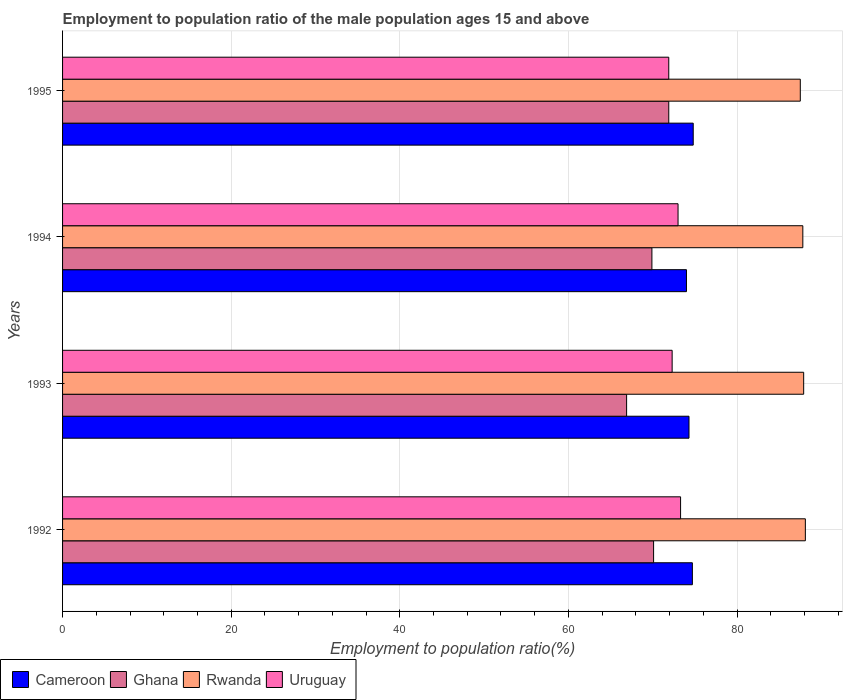How many groups of bars are there?
Your response must be concise. 4. Are the number of bars per tick equal to the number of legend labels?
Ensure brevity in your answer.  Yes. How many bars are there on the 3rd tick from the top?
Make the answer very short. 4. How many bars are there on the 2nd tick from the bottom?
Provide a short and direct response. 4. What is the label of the 1st group of bars from the top?
Keep it short and to the point. 1995. In how many cases, is the number of bars for a given year not equal to the number of legend labels?
Give a very brief answer. 0. What is the employment to population ratio in Cameroon in 1995?
Ensure brevity in your answer.  74.8. Across all years, what is the maximum employment to population ratio in Cameroon?
Ensure brevity in your answer.  74.8. Across all years, what is the minimum employment to population ratio in Cameroon?
Your response must be concise. 74. What is the total employment to population ratio in Ghana in the graph?
Ensure brevity in your answer.  278.8. What is the difference between the employment to population ratio in Cameroon in 1992 and that in 1993?
Make the answer very short. 0.4. What is the average employment to population ratio in Rwanda per year?
Offer a terse response. 87.83. In the year 1995, what is the difference between the employment to population ratio in Uruguay and employment to population ratio in Rwanda?
Your answer should be compact. -15.6. What is the ratio of the employment to population ratio in Rwanda in 1992 to that in 1995?
Your answer should be compact. 1.01. Is the difference between the employment to population ratio in Uruguay in 1993 and 1994 greater than the difference between the employment to population ratio in Rwanda in 1993 and 1994?
Ensure brevity in your answer.  No. What is the difference between the highest and the second highest employment to population ratio in Cameroon?
Offer a terse response. 0.1. What is the difference between the highest and the lowest employment to population ratio in Cameroon?
Keep it short and to the point. 0.8. In how many years, is the employment to population ratio in Cameroon greater than the average employment to population ratio in Cameroon taken over all years?
Your answer should be very brief. 2. What does the 1st bar from the top in 1992 represents?
Offer a very short reply. Uruguay. What does the 4th bar from the bottom in 1995 represents?
Offer a very short reply. Uruguay. How many bars are there?
Provide a short and direct response. 16. Are all the bars in the graph horizontal?
Provide a succinct answer. Yes. How many years are there in the graph?
Offer a terse response. 4. Are the values on the major ticks of X-axis written in scientific E-notation?
Give a very brief answer. No. Does the graph contain any zero values?
Your answer should be very brief. No. Does the graph contain grids?
Offer a very short reply. Yes. How many legend labels are there?
Make the answer very short. 4. How are the legend labels stacked?
Make the answer very short. Horizontal. What is the title of the graph?
Offer a terse response. Employment to population ratio of the male population ages 15 and above. What is the label or title of the X-axis?
Offer a very short reply. Employment to population ratio(%). What is the label or title of the Y-axis?
Provide a short and direct response. Years. What is the Employment to population ratio(%) in Cameroon in 1992?
Provide a succinct answer. 74.7. What is the Employment to population ratio(%) in Ghana in 1992?
Keep it short and to the point. 70.1. What is the Employment to population ratio(%) in Rwanda in 1992?
Your answer should be compact. 88.1. What is the Employment to population ratio(%) in Uruguay in 1992?
Provide a short and direct response. 73.3. What is the Employment to population ratio(%) of Cameroon in 1993?
Make the answer very short. 74.3. What is the Employment to population ratio(%) of Ghana in 1993?
Keep it short and to the point. 66.9. What is the Employment to population ratio(%) in Rwanda in 1993?
Your answer should be compact. 87.9. What is the Employment to population ratio(%) in Uruguay in 1993?
Offer a very short reply. 72.3. What is the Employment to population ratio(%) of Cameroon in 1994?
Your answer should be compact. 74. What is the Employment to population ratio(%) in Ghana in 1994?
Provide a succinct answer. 69.9. What is the Employment to population ratio(%) in Rwanda in 1994?
Your response must be concise. 87.8. What is the Employment to population ratio(%) in Uruguay in 1994?
Your response must be concise. 73. What is the Employment to population ratio(%) of Cameroon in 1995?
Provide a short and direct response. 74.8. What is the Employment to population ratio(%) in Ghana in 1995?
Offer a terse response. 71.9. What is the Employment to population ratio(%) of Rwanda in 1995?
Your answer should be compact. 87.5. What is the Employment to population ratio(%) in Uruguay in 1995?
Offer a very short reply. 71.9. Across all years, what is the maximum Employment to population ratio(%) in Cameroon?
Your response must be concise. 74.8. Across all years, what is the maximum Employment to population ratio(%) of Ghana?
Ensure brevity in your answer.  71.9. Across all years, what is the maximum Employment to population ratio(%) of Rwanda?
Make the answer very short. 88.1. Across all years, what is the maximum Employment to population ratio(%) in Uruguay?
Provide a succinct answer. 73.3. Across all years, what is the minimum Employment to population ratio(%) in Ghana?
Provide a short and direct response. 66.9. Across all years, what is the minimum Employment to population ratio(%) in Rwanda?
Provide a succinct answer. 87.5. Across all years, what is the minimum Employment to population ratio(%) in Uruguay?
Your answer should be very brief. 71.9. What is the total Employment to population ratio(%) of Cameroon in the graph?
Offer a terse response. 297.8. What is the total Employment to population ratio(%) of Ghana in the graph?
Offer a very short reply. 278.8. What is the total Employment to population ratio(%) in Rwanda in the graph?
Make the answer very short. 351.3. What is the total Employment to population ratio(%) in Uruguay in the graph?
Your answer should be compact. 290.5. What is the difference between the Employment to population ratio(%) in Ghana in 1992 and that in 1994?
Make the answer very short. 0.2. What is the difference between the Employment to population ratio(%) of Rwanda in 1992 and that in 1994?
Give a very brief answer. 0.3. What is the difference between the Employment to population ratio(%) in Cameroon in 1992 and that in 1995?
Your answer should be very brief. -0.1. What is the difference between the Employment to population ratio(%) of Rwanda in 1992 and that in 1995?
Provide a short and direct response. 0.6. What is the difference between the Employment to population ratio(%) of Uruguay in 1992 and that in 1995?
Your answer should be very brief. 1.4. What is the difference between the Employment to population ratio(%) in Cameroon in 1993 and that in 1994?
Provide a succinct answer. 0.3. What is the difference between the Employment to population ratio(%) in Rwanda in 1993 and that in 1994?
Your response must be concise. 0.1. What is the difference between the Employment to population ratio(%) in Cameroon in 1993 and that in 1995?
Ensure brevity in your answer.  -0.5. What is the difference between the Employment to population ratio(%) of Ghana in 1993 and that in 1995?
Your response must be concise. -5. What is the difference between the Employment to population ratio(%) in Rwanda in 1993 and that in 1995?
Provide a short and direct response. 0.4. What is the difference between the Employment to population ratio(%) in Cameroon in 1992 and the Employment to population ratio(%) in Ghana in 1993?
Offer a very short reply. 7.8. What is the difference between the Employment to population ratio(%) of Cameroon in 1992 and the Employment to population ratio(%) of Rwanda in 1993?
Give a very brief answer. -13.2. What is the difference between the Employment to population ratio(%) of Ghana in 1992 and the Employment to population ratio(%) of Rwanda in 1993?
Give a very brief answer. -17.8. What is the difference between the Employment to population ratio(%) of Ghana in 1992 and the Employment to population ratio(%) of Uruguay in 1993?
Offer a terse response. -2.2. What is the difference between the Employment to population ratio(%) of Rwanda in 1992 and the Employment to population ratio(%) of Uruguay in 1993?
Offer a very short reply. 15.8. What is the difference between the Employment to population ratio(%) of Cameroon in 1992 and the Employment to population ratio(%) of Ghana in 1994?
Your response must be concise. 4.8. What is the difference between the Employment to population ratio(%) of Cameroon in 1992 and the Employment to population ratio(%) of Rwanda in 1994?
Ensure brevity in your answer.  -13.1. What is the difference between the Employment to population ratio(%) in Cameroon in 1992 and the Employment to population ratio(%) in Uruguay in 1994?
Make the answer very short. 1.7. What is the difference between the Employment to population ratio(%) of Ghana in 1992 and the Employment to population ratio(%) of Rwanda in 1994?
Provide a succinct answer. -17.7. What is the difference between the Employment to population ratio(%) of Rwanda in 1992 and the Employment to population ratio(%) of Uruguay in 1994?
Your response must be concise. 15.1. What is the difference between the Employment to population ratio(%) in Cameroon in 1992 and the Employment to population ratio(%) in Ghana in 1995?
Ensure brevity in your answer.  2.8. What is the difference between the Employment to population ratio(%) in Cameroon in 1992 and the Employment to population ratio(%) in Rwanda in 1995?
Make the answer very short. -12.8. What is the difference between the Employment to population ratio(%) of Cameroon in 1992 and the Employment to population ratio(%) of Uruguay in 1995?
Give a very brief answer. 2.8. What is the difference between the Employment to population ratio(%) of Ghana in 1992 and the Employment to population ratio(%) of Rwanda in 1995?
Make the answer very short. -17.4. What is the difference between the Employment to population ratio(%) of Ghana in 1992 and the Employment to population ratio(%) of Uruguay in 1995?
Offer a terse response. -1.8. What is the difference between the Employment to population ratio(%) of Rwanda in 1992 and the Employment to population ratio(%) of Uruguay in 1995?
Your response must be concise. 16.2. What is the difference between the Employment to population ratio(%) in Cameroon in 1993 and the Employment to population ratio(%) in Ghana in 1994?
Your answer should be very brief. 4.4. What is the difference between the Employment to population ratio(%) in Ghana in 1993 and the Employment to population ratio(%) in Rwanda in 1994?
Provide a succinct answer. -20.9. What is the difference between the Employment to population ratio(%) in Cameroon in 1993 and the Employment to population ratio(%) in Ghana in 1995?
Keep it short and to the point. 2.4. What is the difference between the Employment to population ratio(%) in Cameroon in 1993 and the Employment to population ratio(%) in Rwanda in 1995?
Your response must be concise. -13.2. What is the difference between the Employment to population ratio(%) in Cameroon in 1993 and the Employment to population ratio(%) in Uruguay in 1995?
Give a very brief answer. 2.4. What is the difference between the Employment to population ratio(%) of Ghana in 1993 and the Employment to population ratio(%) of Rwanda in 1995?
Provide a succinct answer. -20.6. What is the difference between the Employment to population ratio(%) of Ghana in 1993 and the Employment to population ratio(%) of Uruguay in 1995?
Your answer should be compact. -5. What is the difference between the Employment to population ratio(%) of Rwanda in 1993 and the Employment to population ratio(%) of Uruguay in 1995?
Provide a succinct answer. 16. What is the difference between the Employment to population ratio(%) of Cameroon in 1994 and the Employment to population ratio(%) of Ghana in 1995?
Give a very brief answer. 2.1. What is the difference between the Employment to population ratio(%) of Cameroon in 1994 and the Employment to population ratio(%) of Rwanda in 1995?
Provide a succinct answer. -13.5. What is the difference between the Employment to population ratio(%) in Cameroon in 1994 and the Employment to population ratio(%) in Uruguay in 1995?
Your answer should be very brief. 2.1. What is the difference between the Employment to population ratio(%) in Ghana in 1994 and the Employment to population ratio(%) in Rwanda in 1995?
Your answer should be very brief. -17.6. What is the difference between the Employment to population ratio(%) in Rwanda in 1994 and the Employment to population ratio(%) in Uruguay in 1995?
Your answer should be very brief. 15.9. What is the average Employment to population ratio(%) of Cameroon per year?
Provide a short and direct response. 74.45. What is the average Employment to population ratio(%) of Ghana per year?
Your response must be concise. 69.7. What is the average Employment to population ratio(%) in Rwanda per year?
Your answer should be very brief. 87.83. What is the average Employment to population ratio(%) in Uruguay per year?
Ensure brevity in your answer.  72.62. In the year 1992, what is the difference between the Employment to population ratio(%) of Cameroon and Employment to population ratio(%) of Ghana?
Offer a terse response. 4.6. In the year 1992, what is the difference between the Employment to population ratio(%) of Ghana and Employment to population ratio(%) of Uruguay?
Your answer should be compact. -3.2. In the year 1993, what is the difference between the Employment to population ratio(%) of Cameroon and Employment to population ratio(%) of Uruguay?
Your answer should be very brief. 2. In the year 1993, what is the difference between the Employment to population ratio(%) of Ghana and Employment to population ratio(%) of Uruguay?
Offer a very short reply. -5.4. In the year 1994, what is the difference between the Employment to population ratio(%) in Cameroon and Employment to population ratio(%) in Uruguay?
Provide a succinct answer. 1. In the year 1994, what is the difference between the Employment to population ratio(%) in Ghana and Employment to population ratio(%) in Rwanda?
Give a very brief answer. -17.9. In the year 1994, what is the difference between the Employment to population ratio(%) of Rwanda and Employment to population ratio(%) of Uruguay?
Provide a succinct answer. 14.8. In the year 1995, what is the difference between the Employment to population ratio(%) of Cameroon and Employment to population ratio(%) of Ghana?
Give a very brief answer. 2.9. In the year 1995, what is the difference between the Employment to population ratio(%) in Cameroon and Employment to population ratio(%) in Rwanda?
Provide a short and direct response. -12.7. In the year 1995, what is the difference between the Employment to population ratio(%) of Cameroon and Employment to population ratio(%) of Uruguay?
Provide a short and direct response. 2.9. In the year 1995, what is the difference between the Employment to population ratio(%) in Ghana and Employment to population ratio(%) in Rwanda?
Give a very brief answer. -15.6. In the year 1995, what is the difference between the Employment to population ratio(%) of Ghana and Employment to population ratio(%) of Uruguay?
Keep it short and to the point. 0. What is the ratio of the Employment to population ratio(%) in Cameroon in 1992 to that in 1993?
Keep it short and to the point. 1.01. What is the ratio of the Employment to population ratio(%) of Ghana in 1992 to that in 1993?
Offer a terse response. 1.05. What is the ratio of the Employment to population ratio(%) in Uruguay in 1992 to that in 1993?
Offer a terse response. 1.01. What is the ratio of the Employment to population ratio(%) of Cameroon in 1992 to that in 1994?
Provide a short and direct response. 1.01. What is the ratio of the Employment to population ratio(%) in Rwanda in 1992 to that in 1994?
Offer a terse response. 1. What is the ratio of the Employment to population ratio(%) in Rwanda in 1992 to that in 1995?
Provide a succinct answer. 1.01. What is the ratio of the Employment to population ratio(%) in Uruguay in 1992 to that in 1995?
Provide a short and direct response. 1.02. What is the ratio of the Employment to population ratio(%) in Cameroon in 1993 to that in 1994?
Keep it short and to the point. 1. What is the ratio of the Employment to population ratio(%) in Ghana in 1993 to that in 1994?
Your response must be concise. 0.96. What is the ratio of the Employment to population ratio(%) in Rwanda in 1993 to that in 1994?
Your answer should be compact. 1. What is the ratio of the Employment to population ratio(%) in Uruguay in 1993 to that in 1994?
Your answer should be very brief. 0.99. What is the ratio of the Employment to population ratio(%) in Ghana in 1993 to that in 1995?
Ensure brevity in your answer.  0.93. What is the ratio of the Employment to population ratio(%) of Uruguay in 1993 to that in 1995?
Ensure brevity in your answer.  1.01. What is the ratio of the Employment to population ratio(%) in Cameroon in 1994 to that in 1995?
Offer a terse response. 0.99. What is the ratio of the Employment to population ratio(%) of Ghana in 1994 to that in 1995?
Give a very brief answer. 0.97. What is the ratio of the Employment to population ratio(%) of Rwanda in 1994 to that in 1995?
Offer a terse response. 1. What is the ratio of the Employment to population ratio(%) in Uruguay in 1994 to that in 1995?
Your answer should be very brief. 1.02. What is the difference between the highest and the second highest Employment to population ratio(%) of Ghana?
Your answer should be very brief. 1.8. What is the difference between the highest and the second highest Employment to population ratio(%) in Rwanda?
Give a very brief answer. 0.2. What is the difference between the highest and the lowest Employment to population ratio(%) of Uruguay?
Provide a succinct answer. 1.4. 